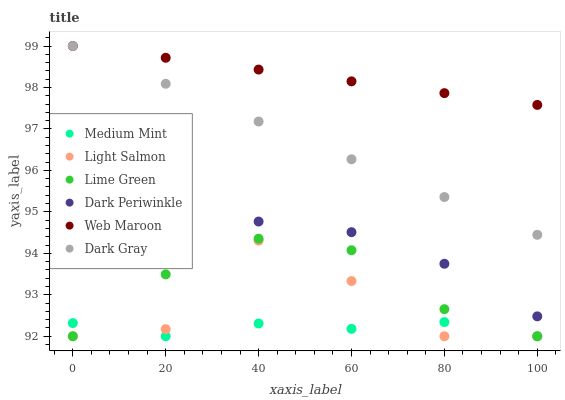Does Medium Mint have the minimum area under the curve?
Answer yes or no. Yes. Does Web Maroon have the maximum area under the curve?
Answer yes or no. Yes. Does Light Salmon have the minimum area under the curve?
Answer yes or no. No. Does Light Salmon have the maximum area under the curve?
Answer yes or no. No. Is Web Maroon the smoothest?
Answer yes or no. Yes. Is Light Salmon the roughest?
Answer yes or no. Yes. Is Light Salmon the smoothest?
Answer yes or no. No. Is Web Maroon the roughest?
Answer yes or no. No. Does Medium Mint have the lowest value?
Answer yes or no. Yes. Does Web Maroon have the lowest value?
Answer yes or no. No. Does Dark Gray have the highest value?
Answer yes or no. Yes. Does Light Salmon have the highest value?
Answer yes or no. No. Is Light Salmon less than Web Maroon?
Answer yes or no. Yes. Is Dark Gray greater than Medium Mint?
Answer yes or no. Yes. Does Medium Mint intersect Light Salmon?
Answer yes or no. Yes. Is Medium Mint less than Light Salmon?
Answer yes or no. No. Is Medium Mint greater than Light Salmon?
Answer yes or no. No. Does Light Salmon intersect Web Maroon?
Answer yes or no. No. 